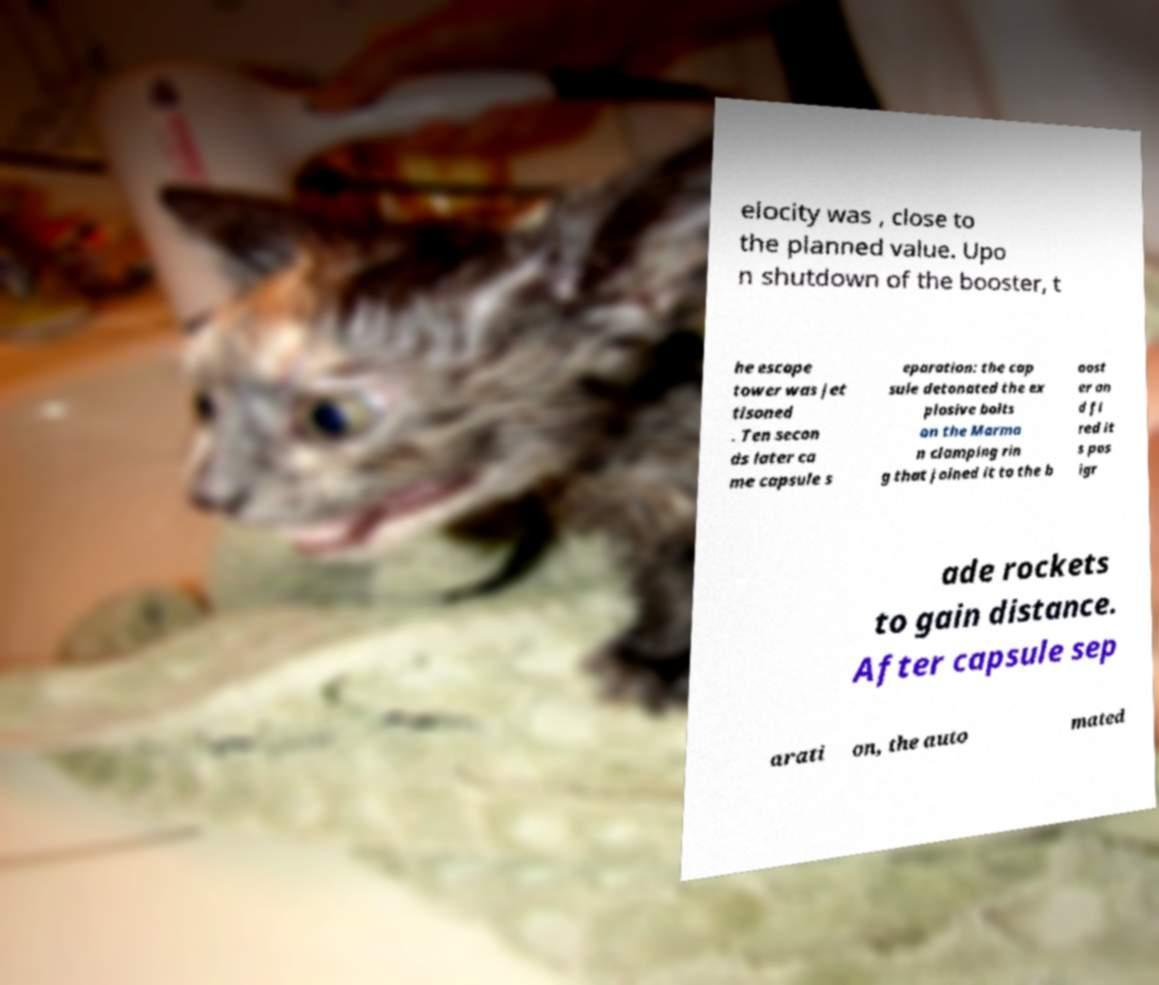Could you extract and type out the text from this image? elocity was , close to the planned value. Upo n shutdown of the booster, t he escape tower was jet tisoned . Ten secon ds later ca me capsule s eparation: the cap sule detonated the ex plosive bolts on the Marma n clamping rin g that joined it to the b oost er an d fi red it s pos igr ade rockets to gain distance. After capsule sep arati on, the auto mated 